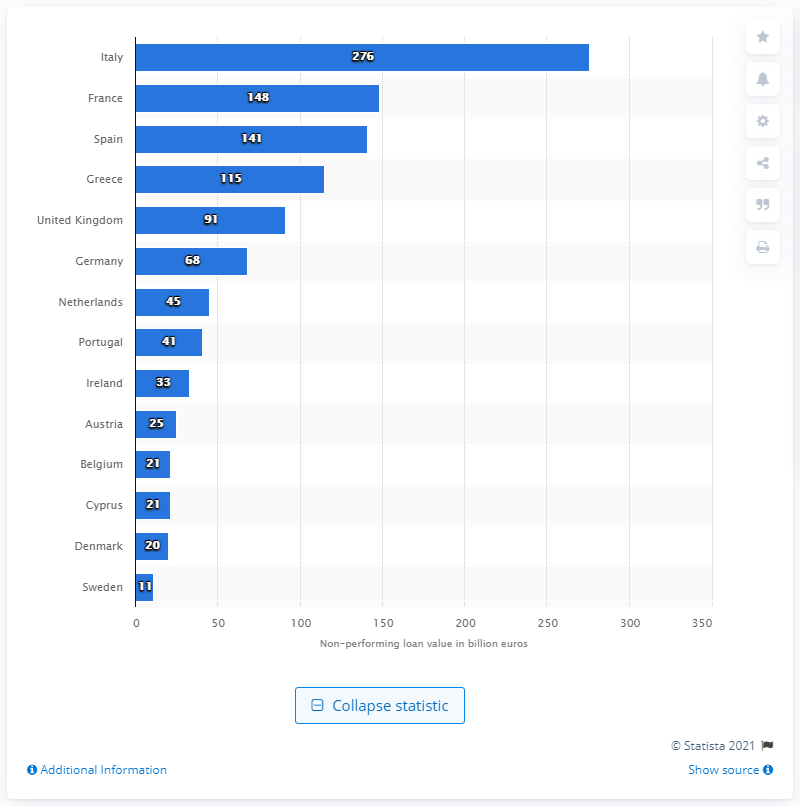Specify some key components in this picture. The highest value of Italian non-performing loans was 276... In June 2016, the value of non-performing loans in France and Spain was 276. 